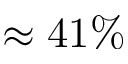<formula> <loc_0><loc_0><loc_500><loc_500>\approx 4 1 \%</formula> 